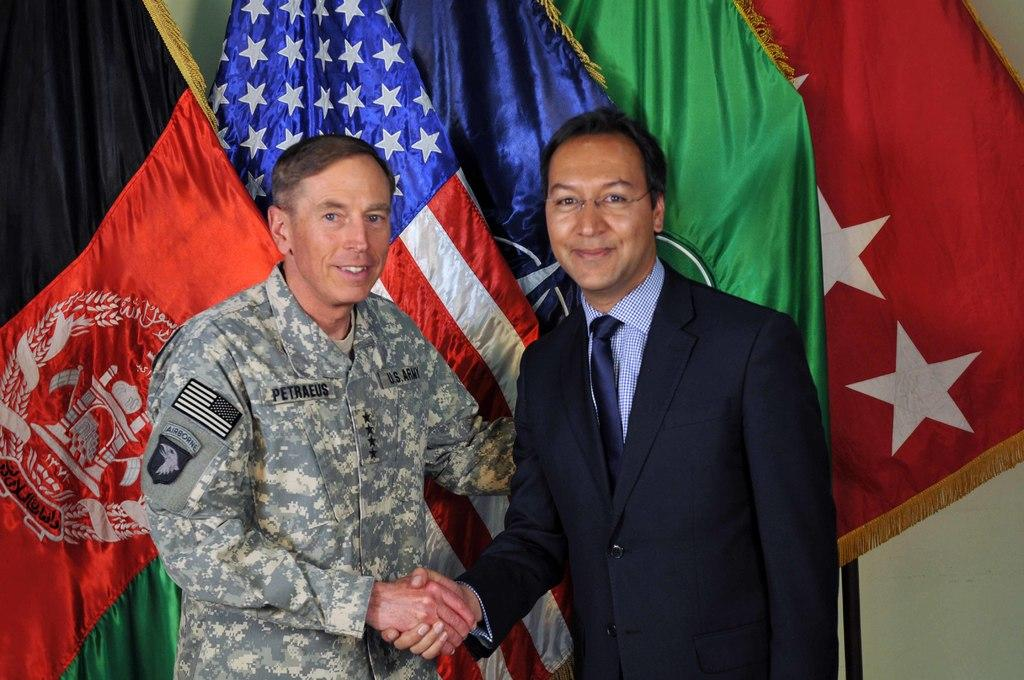How many people are in the image? There are two persons standing in the middle of the image. What are the people doing in the image? The persons are smiling. What can be seen behind the people? There are flags behind the persons. What is located behind the flags? There is a wall behind the flags. What type of impulse is the mother experiencing in the image? There is no mother present in the image, and therefore no impulse can be attributed to her. 